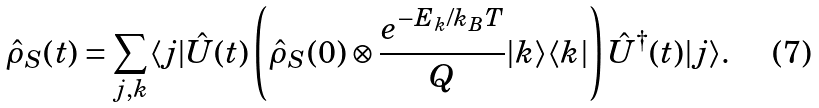<formula> <loc_0><loc_0><loc_500><loc_500>\hat { \rho } _ { S } ( t ) = \sum _ { j , k } \langle j | \hat { U } ( t ) \left ( \hat { \rho } _ { S } ( 0 ) \otimes \frac { e ^ { - E _ { k } / k _ { B } T } } { Q } | k \rangle \langle k | \right ) \hat { U } ^ { \dagger } ( t ) | j \rangle .</formula> 